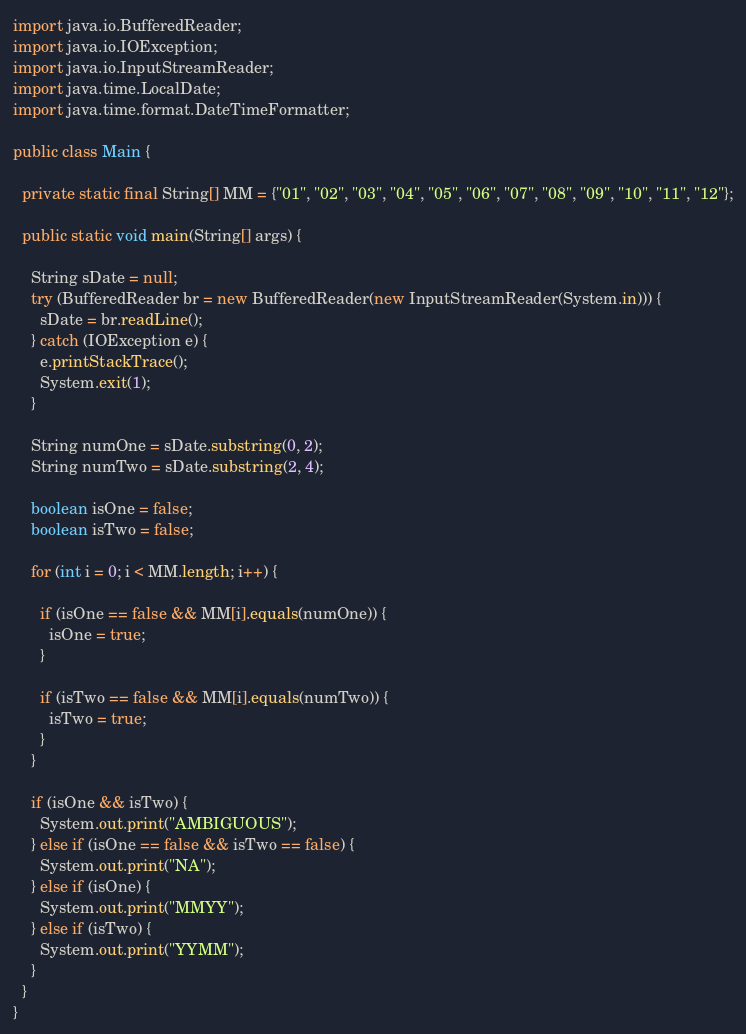<code> <loc_0><loc_0><loc_500><loc_500><_Java_>import java.io.BufferedReader;
import java.io.IOException;
import java.io.InputStreamReader;
import java.time.LocalDate;
import java.time.format.DateTimeFormatter;

public class Main {

  private static final String[] MM = {"01", "02", "03", "04", "05", "06", "07", "08", "09", "10", "11", "12"};

  public static void main(String[] args) {

    String sDate = null;
    try (BufferedReader br = new BufferedReader(new InputStreamReader(System.in))) {
      sDate = br.readLine();
    } catch (IOException e) {
      e.printStackTrace();
      System.exit(1);
    }

    String numOne = sDate.substring(0, 2);
    String numTwo = sDate.substring(2, 4);

    boolean isOne = false;
    boolean isTwo = false;

    for (int i = 0; i < MM.length; i++) {

      if (isOne == false && MM[i].equals(numOne)) {
        isOne = true;
      }

      if (isTwo == false && MM[i].equals(numTwo)) {
        isTwo = true;
      }
    }

    if (isOne && isTwo) {
      System.out.print("AMBIGUOUS");
    } else if (isOne == false && isTwo == false) {
      System.out.print("NA");
    } else if (isOne) {
      System.out.print("MMYY");
    } else if (isTwo) {
      System.out.print("YYMM");
    }
  }
}
</code> 